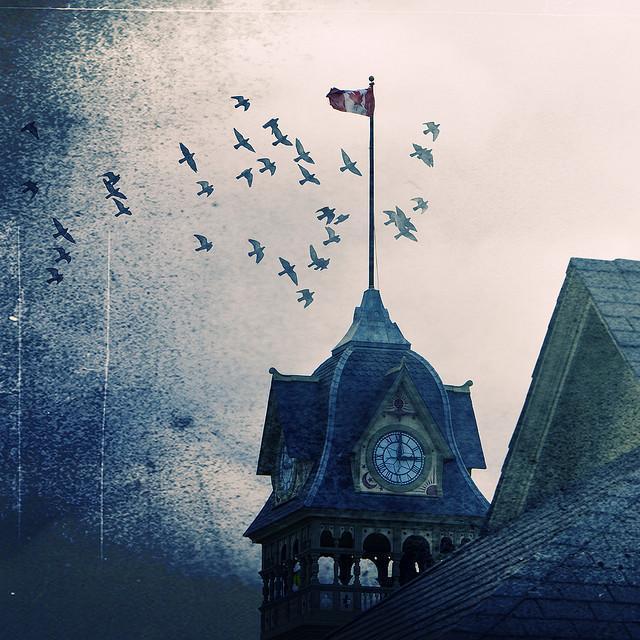What nation's flag are the birds flying towards?
Make your selection from the four choices given to correctly answer the question.
Options: Colombia, romania, switzerland, canada. Canada. 